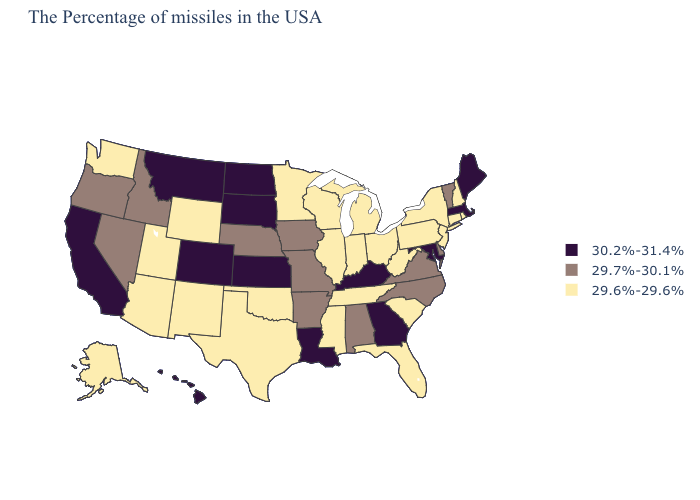What is the lowest value in the Northeast?
Write a very short answer. 29.6%-29.6%. Name the states that have a value in the range 30.2%-31.4%?
Answer briefly. Maine, Massachusetts, Maryland, Georgia, Kentucky, Louisiana, Kansas, South Dakota, North Dakota, Colorado, Montana, California, Hawaii. Among the states that border Kansas , does Colorado have the highest value?
Keep it brief. Yes. What is the highest value in the Northeast ?
Quick response, please. 30.2%-31.4%. Which states have the highest value in the USA?
Write a very short answer. Maine, Massachusetts, Maryland, Georgia, Kentucky, Louisiana, Kansas, South Dakota, North Dakota, Colorado, Montana, California, Hawaii. What is the value of Montana?
Be succinct. 30.2%-31.4%. Does the first symbol in the legend represent the smallest category?
Be succinct. No. Which states have the highest value in the USA?
Write a very short answer. Maine, Massachusetts, Maryland, Georgia, Kentucky, Louisiana, Kansas, South Dakota, North Dakota, Colorado, Montana, California, Hawaii. Name the states that have a value in the range 30.2%-31.4%?
Answer briefly. Maine, Massachusetts, Maryland, Georgia, Kentucky, Louisiana, Kansas, South Dakota, North Dakota, Colorado, Montana, California, Hawaii. Name the states that have a value in the range 30.2%-31.4%?
Keep it brief. Maine, Massachusetts, Maryland, Georgia, Kentucky, Louisiana, Kansas, South Dakota, North Dakota, Colorado, Montana, California, Hawaii. Is the legend a continuous bar?
Be succinct. No. Does the map have missing data?
Answer briefly. No. Does the first symbol in the legend represent the smallest category?
Be succinct. No. Which states have the lowest value in the USA?
Short answer required. Rhode Island, New Hampshire, Connecticut, New York, New Jersey, Pennsylvania, South Carolina, West Virginia, Ohio, Florida, Michigan, Indiana, Tennessee, Wisconsin, Illinois, Mississippi, Minnesota, Oklahoma, Texas, Wyoming, New Mexico, Utah, Arizona, Washington, Alaska. What is the value of Arkansas?
Concise answer only. 29.7%-30.1%. 